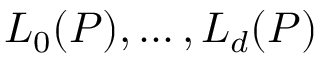Convert formula to latex. <formula><loc_0><loc_0><loc_500><loc_500>L _ { 0 } ( P ) , \dots , L _ { d } ( P )</formula> 